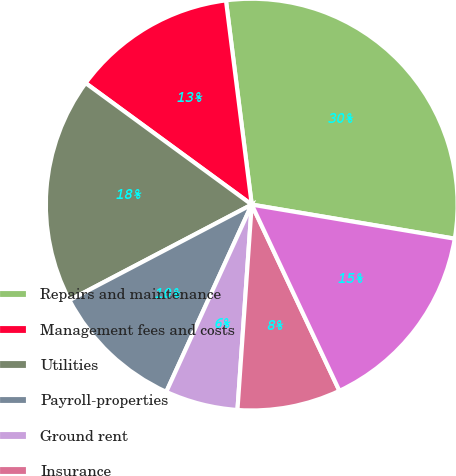Convert chart. <chart><loc_0><loc_0><loc_500><loc_500><pie_chart><fcel>Repairs and maintenance<fcel>Management fees and costs<fcel>Utilities<fcel>Payroll-properties<fcel>Ground rent<fcel>Insurance<fcel>Other<nl><fcel>29.65%<fcel>12.95%<fcel>17.74%<fcel>10.5%<fcel>5.71%<fcel>8.11%<fcel>15.35%<nl></chart> 